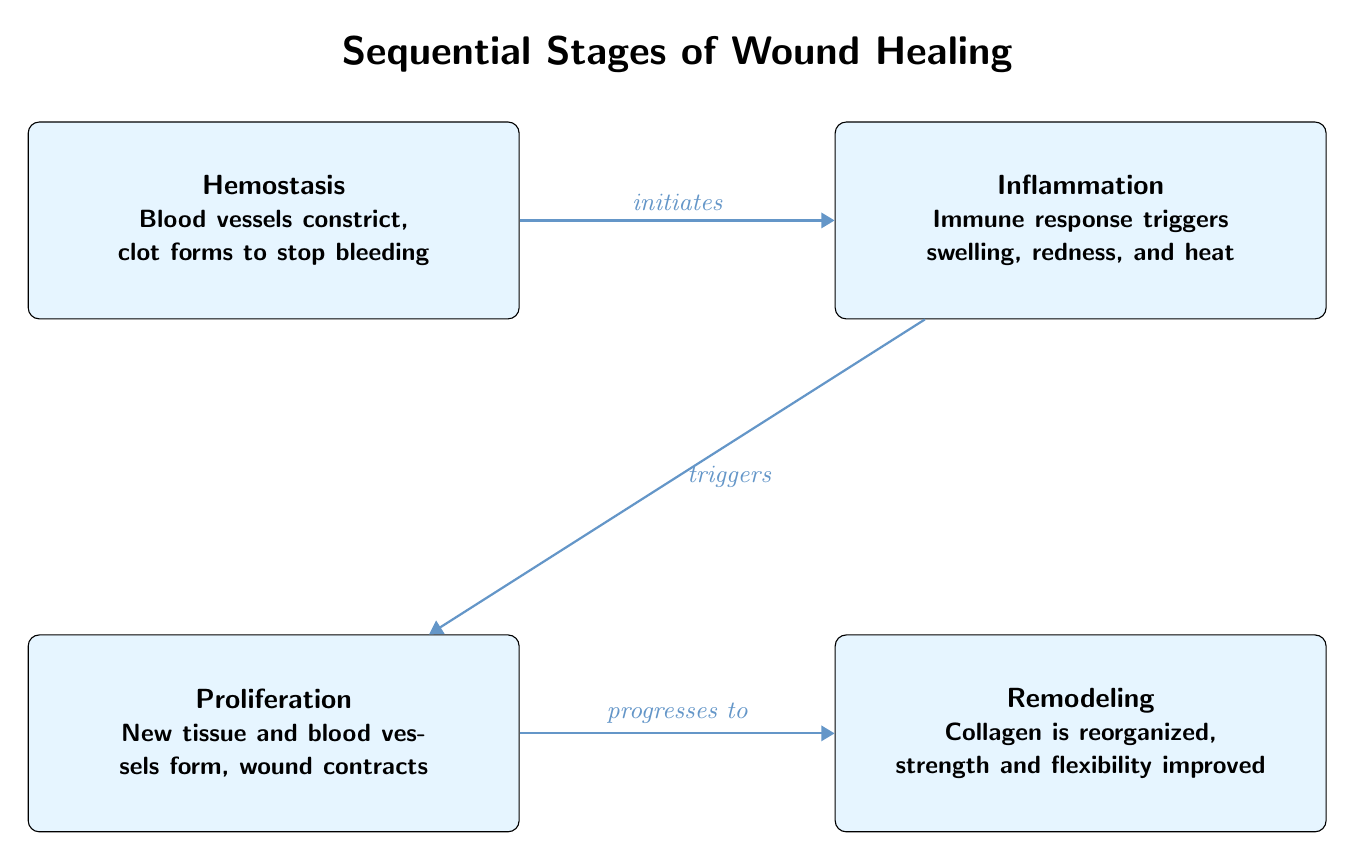What is the first stage of wound healing? The diagram displays four stages, with the first stage labeled as "Hemostasis." This is confirmed by observing the uppermost node that initiates the process.
Answer: Hemostasis What triggers the proliferation stage? The arrow from the inflammation stage (the second node) to the proliferation stage indicates that inflammation triggers the formation of new tissue and blood vessels, which is the third stage.
Answer: Inflammation How many stages are there in total? The diagram contains four distinct nodes, each representing a unique stage in the wound healing process. Counting each node confirms this total.
Answer: Four What relationship does hemostasis have with inflammation? The diagram shows an arrow from the hemostasis stage to the inflammation stage, labeled "initiates," indicating that hemostasis acts as the precursor to inflammation, setting off the healing process.
Answer: Initiates What is the key activity that occurs in the remodeling stage? The remodeling stage, which is the final node, describes the reorganization of collagen, indicating a focus on strengthening and improving the flexibility of the healed tissue as part of the healing process.
Answer: Collagen is reorganized What happens after the proliferation stage? According to the diagram, the proliferation stage leads directly to the remodeling stage, indicated by the arrow labeled "progresses to." Thus, the next stage after proliferation is remodeling.
Answer: Remodeling Which stage involves the immune response? The inflammation stage details the immune response, characterized by swelling, redness, and heat, as shown in the second node of the diagram. This is a clear indication of the stage's primary focus.
Answer: Inflammation How do hemostasis and remodeling stages compare in terms of order? By observing the sequence of the arrows in the diagram, it is evident that hemostasis occurs first, followed by inflammation, proliferation, and then remodeling, indicating their chronological order.
Answer: First What does the proliferation stage describe? The proliferation stage is described by the formation of new tissues and blood vessels, which is crucial for wound closure and healing, as highlighted in the third stage of the diagram.
Answer: New tissue and blood vessels form 